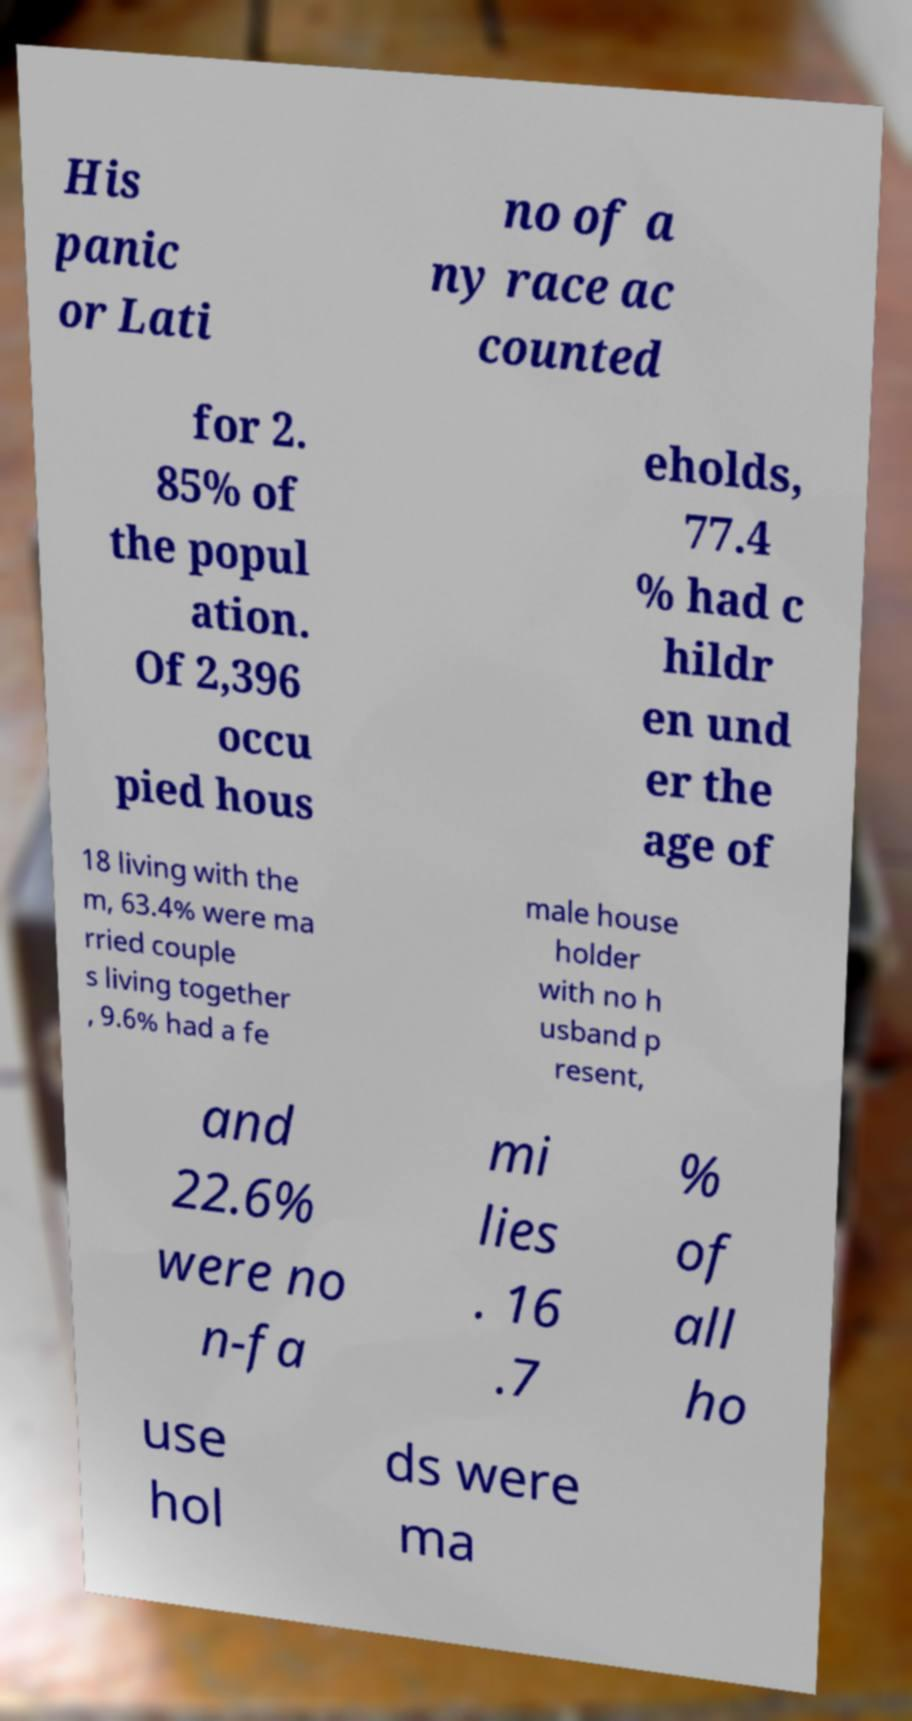Please identify and transcribe the text found in this image. His panic or Lati no of a ny race ac counted for 2. 85% of the popul ation. Of 2,396 occu pied hous eholds, 77.4 % had c hildr en und er the age of 18 living with the m, 63.4% were ma rried couple s living together , 9.6% had a fe male house holder with no h usband p resent, and 22.6% were no n-fa mi lies . 16 .7 % of all ho use hol ds were ma 